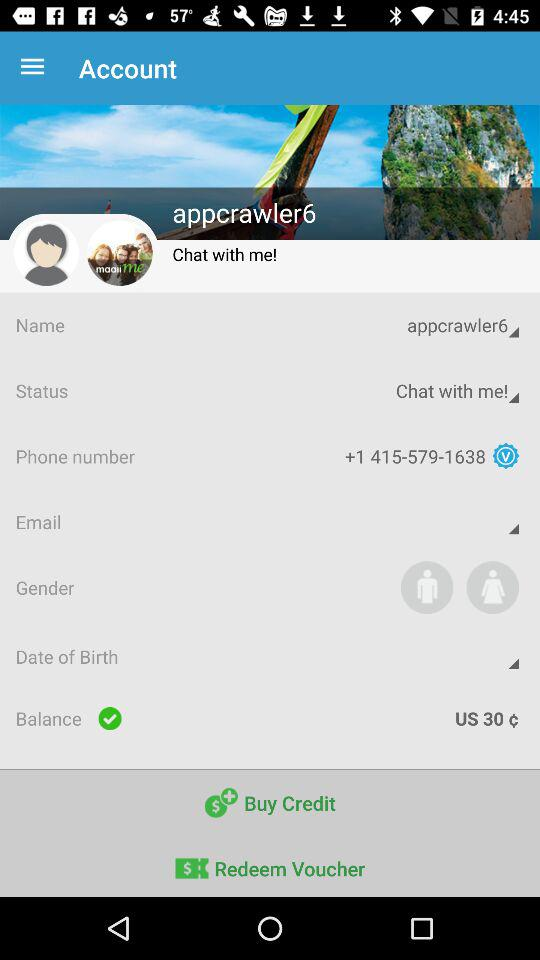What is the phone number? The phone number is +1 415-579-1638. 